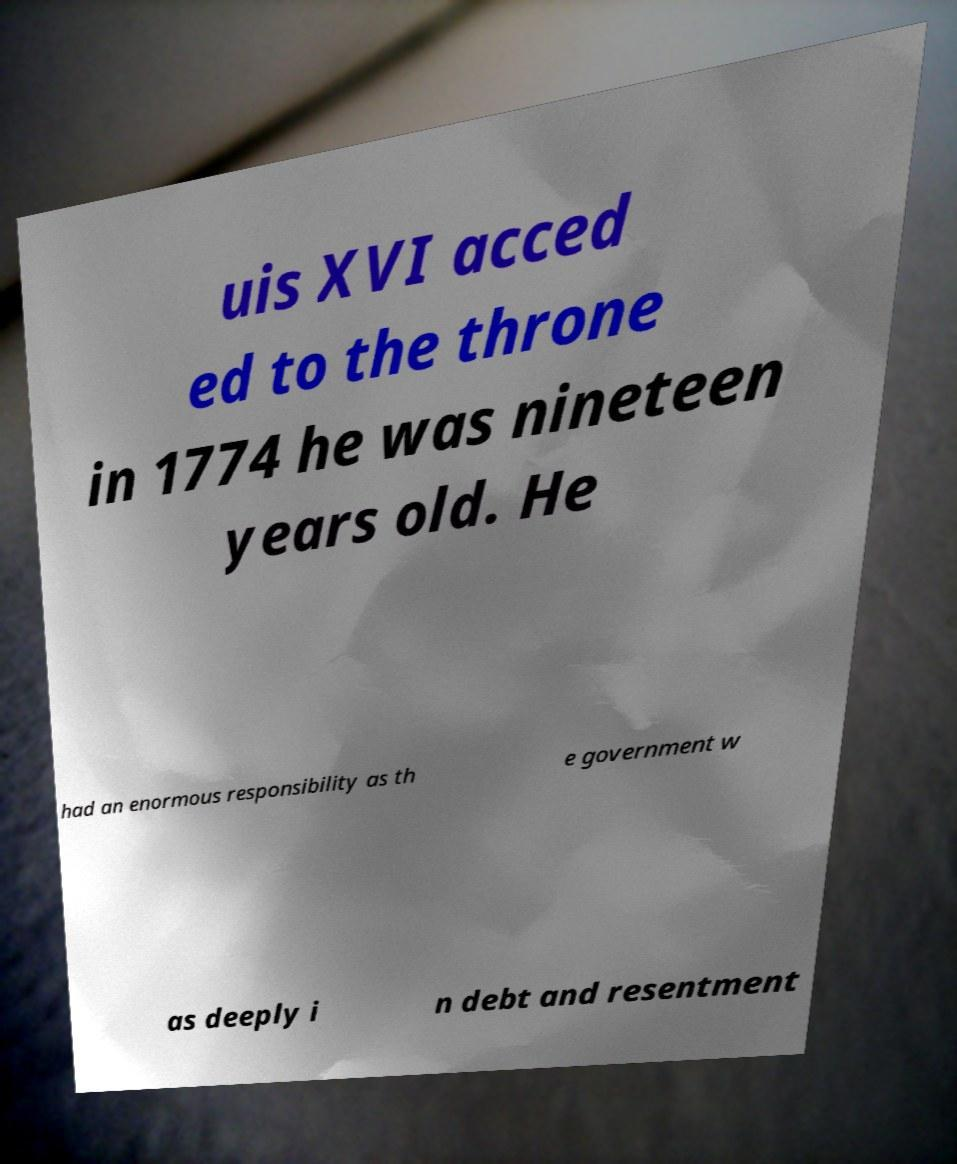I need the written content from this picture converted into text. Can you do that? uis XVI acced ed to the throne in 1774 he was nineteen years old. He had an enormous responsibility as th e government w as deeply i n debt and resentment 